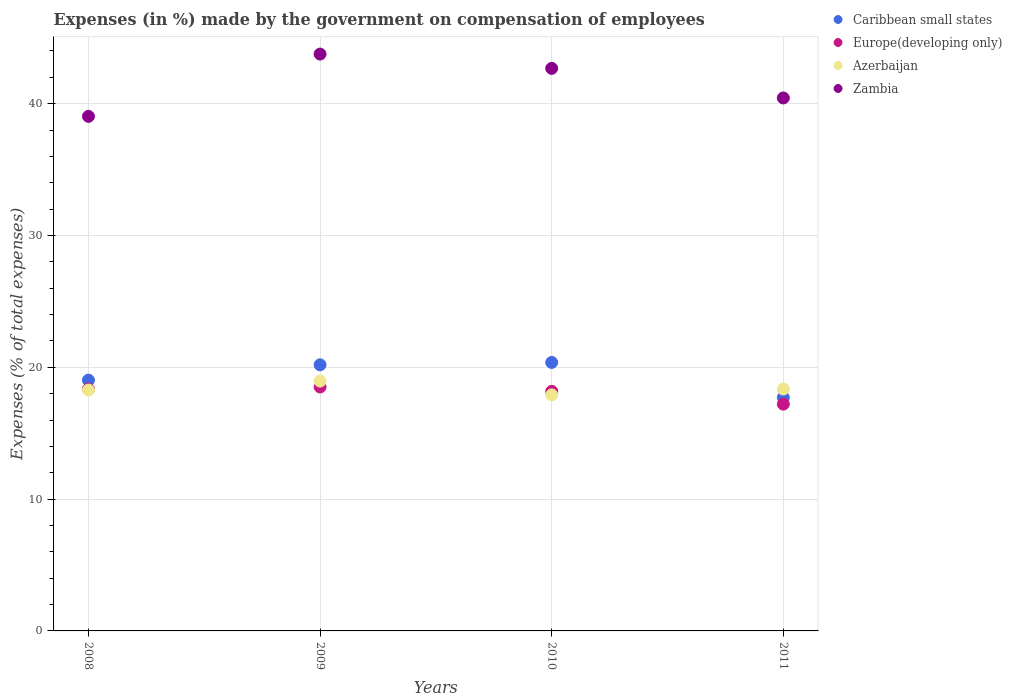What is the percentage of expenses made by the government on compensation of employees in Europe(developing only) in 2008?
Keep it short and to the point. 18.35. Across all years, what is the maximum percentage of expenses made by the government on compensation of employees in Caribbean small states?
Your response must be concise. 20.37. Across all years, what is the minimum percentage of expenses made by the government on compensation of employees in Caribbean small states?
Provide a short and direct response. 17.71. In which year was the percentage of expenses made by the government on compensation of employees in Caribbean small states maximum?
Provide a succinct answer. 2010. In which year was the percentage of expenses made by the government on compensation of employees in Caribbean small states minimum?
Make the answer very short. 2011. What is the total percentage of expenses made by the government on compensation of employees in Europe(developing only) in the graph?
Make the answer very short. 72.23. What is the difference between the percentage of expenses made by the government on compensation of employees in Zambia in 2008 and that in 2009?
Offer a terse response. -4.73. What is the difference between the percentage of expenses made by the government on compensation of employees in Zambia in 2011 and the percentage of expenses made by the government on compensation of employees in Europe(developing only) in 2008?
Offer a very short reply. 22.08. What is the average percentage of expenses made by the government on compensation of employees in Caribbean small states per year?
Make the answer very short. 19.32. In the year 2009, what is the difference between the percentage of expenses made by the government on compensation of employees in Azerbaijan and percentage of expenses made by the government on compensation of employees in Caribbean small states?
Provide a short and direct response. -1.23. In how many years, is the percentage of expenses made by the government on compensation of employees in Azerbaijan greater than 6 %?
Keep it short and to the point. 4. What is the ratio of the percentage of expenses made by the government on compensation of employees in Zambia in 2008 to that in 2010?
Give a very brief answer. 0.91. Is the percentage of expenses made by the government on compensation of employees in Europe(developing only) in 2008 less than that in 2010?
Your response must be concise. No. What is the difference between the highest and the second highest percentage of expenses made by the government on compensation of employees in Zambia?
Make the answer very short. 1.08. What is the difference between the highest and the lowest percentage of expenses made by the government on compensation of employees in Europe(developing only)?
Your response must be concise. 1.3. In how many years, is the percentage of expenses made by the government on compensation of employees in Azerbaijan greater than the average percentage of expenses made by the government on compensation of employees in Azerbaijan taken over all years?
Offer a terse response. 1. Is the sum of the percentage of expenses made by the government on compensation of employees in Europe(developing only) in 2009 and 2010 greater than the maximum percentage of expenses made by the government on compensation of employees in Caribbean small states across all years?
Ensure brevity in your answer.  Yes. Is it the case that in every year, the sum of the percentage of expenses made by the government on compensation of employees in Zambia and percentage of expenses made by the government on compensation of employees in Europe(developing only)  is greater than the sum of percentage of expenses made by the government on compensation of employees in Caribbean small states and percentage of expenses made by the government on compensation of employees in Azerbaijan?
Make the answer very short. Yes. Does the percentage of expenses made by the government on compensation of employees in Europe(developing only) monotonically increase over the years?
Ensure brevity in your answer.  No. Is the percentage of expenses made by the government on compensation of employees in Zambia strictly greater than the percentage of expenses made by the government on compensation of employees in Azerbaijan over the years?
Your answer should be very brief. Yes. What is the difference between two consecutive major ticks on the Y-axis?
Provide a succinct answer. 10. Are the values on the major ticks of Y-axis written in scientific E-notation?
Your response must be concise. No. Does the graph contain grids?
Provide a short and direct response. Yes. Where does the legend appear in the graph?
Make the answer very short. Top right. How many legend labels are there?
Offer a very short reply. 4. How are the legend labels stacked?
Your answer should be very brief. Vertical. What is the title of the graph?
Keep it short and to the point. Expenses (in %) made by the government on compensation of employees. Does "El Salvador" appear as one of the legend labels in the graph?
Your answer should be very brief. No. What is the label or title of the Y-axis?
Your response must be concise. Expenses (% of total expenses). What is the Expenses (% of total expenses) in Caribbean small states in 2008?
Keep it short and to the point. 19.03. What is the Expenses (% of total expenses) of Europe(developing only) in 2008?
Give a very brief answer. 18.35. What is the Expenses (% of total expenses) of Azerbaijan in 2008?
Your response must be concise. 18.27. What is the Expenses (% of total expenses) of Zambia in 2008?
Keep it short and to the point. 39.03. What is the Expenses (% of total expenses) of Caribbean small states in 2009?
Ensure brevity in your answer.  20.19. What is the Expenses (% of total expenses) in Europe(developing only) in 2009?
Make the answer very short. 18.5. What is the Expenses (% of total expenses) in Azerbaijan in 2009?
Provide a short and direct response. 18.95. What is the Expenses (% of total expenses) in Zambia in 2009?
Give a very brief answer. 43.76. What is the Expenses (% of total expenses) in Caribbean small states in 2010?
Your answer should be compact. 20.37. What is the Expenses (% of total expenses) of Europe(developing only) in 2010?
Your answer should be very brief. 18.17. What is the Expenses (% of total expenses) in Azerbaijan in 2010?
Give a very brief answer. 17.91. What is the Expenses (% of total expenses) of Zambia in 2010?
Make the answer very short. 42.68. What is the Expenses (% of total expenses) of Caribbean small states in 2011?
Your answer should be compact. 17.71. What is the Expenses (% of total expenses) in Europe(developing only) in 2011?
Offer a terse response. 17.21. What is the Expenses (% of total expenses) in Azerbaijan in 2011?
Provide a short and direct response. 18.35. What is the Expenses (% of total expenses) of Zambia in 2011?
Your response must be concise. 40.43. Across all years, what is the maximum Expenses (% of total expenses) in Caribbean small states?
Provide a succinct answer. 20.37. Across all years, what is the maximum Expenses (% of total expenses) in Europe(developing only)?
Your response must be concise. 18.5. Across all years, what is the maximum Expenses (% of total expenses) in Azerbaijan?
Provide a succinct answer. 18.95. Across all years, what is the maximum Expenses (% of total expenses) in Zambia?
Give a very brief answer. 43.76. Across all years, what is the minimum Expenses (% of total expenses) of Caribbean small states?
Give a very brief answer. 17.71. Across all years, what is the minimum Expenses (% of total expenses) in Europe(developing only)?
Give a very brief answer. 17.21. Across all years, what is the minimum Expenses (% of total expenses) in Azerbaijan?
Your answer should be compact. 17.91. Across all years, what is the minimum Expenses (% of total expenses) in Zambia?
Provide a short and direct response. 39.03. What is the total Expenses (% of total expenses) of Caribbean small states in the graph?
Your answer should be very brief. 77.29. What is the total Expenses (% of total expenses) in Europe(developing only) in the graph?
Your answer should be very brief. 72.23. What is the total Expenses (% of total expenses) in Azerbaijan in the graph?
Your answer should be compact. 73.48. What is the total Expenses (% of total expenses) in Zambia in the graph?
Give a very brief answer. 165.9. What is the difference between the Expenses (% of total expenses) in Caribbean small states in 2008 and that in 2009?
Your answer should be very brief. -1.16. What is the difference between the Expenses (% of total expenses) of Europe(developing only) in 2008 and that in 2009?
Give a very brief answer. -0.16. What is the difference between the Expenses (% of total expenses) of Azerbaijan in 2008 and that in 2009?
Your response must be concise. -0.68. What is the difference between the Expenses (% of total expenses) in Zambia in 2008 and that in 2009?
Give a very brief answer. -4.73. What is the difference between the Expenses (% of total expenses) in Caribbean small states in 2008 and that in 2010?
Keep it short and to the point. -1.34. What is the difference between the Expenses (% of total expenses) of Europe(developing only) in 2008 and that in 2010?
Provide a short and direct response. 0.17. What is the difference between the Expenses (% of total expenses) of Azerbaijan in 2008 and that in 2010?
Provide a succinct answer. 0.37. What is the difference between the Expenses (% of total expenses) in Zambia in 2008 and that in 2010?
Offer a very short reply. -3.64. What is the difference between the Expenses (% of total expenses) in Caribbean small states in 2008 and that in 2011?
Your answer should be compact. 1.32. What is the difference between the Expenses (% of total expenses) in Europe(developing only) in 2008 and that in 2011?
Your answer should be very brief. 1.14. What is the difference between the Expenses (% of total expenses) of Azerbaijan in 2008 and that in 2011?
Make the answer very short. -0.07. What is the difference between the Expenses (% of total expenses) in Zambia in 2008 and that in 2011?
Offer a terse response. -1.4. What is the difference between the Expenses (% of total expenses) of Caribbean small states in 2009 and that in 2010?
Make the answer very short. -0.18. What is the difference between the Expenses (% of total expenses) of Europe(developing only) in 2009 and that in 2010?
Ensure brevity in your answer.  0.33. What is the difference between the Expenses (% of total expenses) of Azerbaijan in 2009 and that in 2010?
Give a very brief answer. 1.04. What is the difference between the Expenses (% of total expenses) of Zambia in 2009 and that in 2010?
Offer a terse response. 1.08. What is the difference between the Expenses (% of total expenses) in Caribbean small states in 2009 and that in 2011?
Your response must be concise. 2.48. What is the difference between the Expenses (% of total expenses) in Europe(developing only) in 2009 and that in 2011?
Offer a terse response. 1.3. What is the difference between the Expenses (% of total expenses) of Azerbaijan in 2009 and that in 2011?
Offer a very short reply. 0.6. What is the difference between the Expenses (% of total expenses) of Zambia in 2009 and that in 2011?
Your answer should be compact. 3.33. What is the difference between the Expenses (% of total expenses) in Caribbean small states in 2010 and that in 2011?
Your answer should be compact. 2.66. What is the difference between the Expenses (% of total expenses) in Europe(developing only) in 2010 and that in 2011?
Offer a terse response. 0.97. What is the difference between the Expenses (% of total expenses) of Azerbaijan in 2010 and that in 2011?
Provide a short and direct response. -0.44. What is the difference between the Expenses (% of total expenses) of Zambia in 2010 and that in 2011?
Your response must be concise. 2.24. What is the difference between the Expenses (% of total expenses) of Caribbean small states in 2008 and the Expenses (% of total expenses) of Europe(developing only) in 2009?
Provide a succinct answer. 0.52. What is the difference between the Expenses (% of total expenses) of Caribbean small states in 2008 and the Expenses (% of total expenses) of Azerbaijan in 2009?
Keep it short and to the point. 0.07. What is the difference between the Expenses (% of total expenses) of Caribbean small states in 2008 and the Expenses (% of total expenses) of Zambia in 2009?
Give a very brief answer. -24.73. What is the difference between the Expenses (% of total expenses) in Europe(developing only) in 2008 and the Expenses (% of total expenses) in Azerbaijan in 2009?
Your answer should be very brief. -0.6. What is the difference between the Expenses (% of total expenses) of Europe(developing only) in 2008 and the Expenses (% of total expenses) of Zambia in 2009?
Make the answer very short. -25.41. What is the difference between the Expenses (% of total expenses) of Azerbaijan in 2008 and the Expenses (% of total expenses) of Zambia in 2009?
Make the answer very short. -25.49. What is the difference between the Expenses (% of total expenses) in Caribbean small states in 2008 and the Expenses (% of total expenses) in Europe(developing only) in 2010?
Give a very brief answer. 0.85. What is the difference between the Expenses (% of total expenses) of Caribbean small states in 2008 and the Expenses (% of total expenses) of Azerbaijan in 2010?
Provide a succinct answer. 1.12. What is the difference between the Expenses (% of total expenses) of Caribbean small states in 2008 and the Expenses (% of total expenses) of Zambia in 2010?
Make the answer very short. -23.65. What is the difference between the Expenses (% of total expenses) in Europe(developing only) in 2008 and the Expenses (% of total expenses) in Azerbaijan in 2010?
Your response must be concise. 0.44. What is the difference between the Expenses (% of total expenses) of Europe(developing only) in 2008 and the Expenses (% of total expenses) of Zambia in 2010?
Offer a terse response. -24.33. What is the difference between the Expenses (% of total expenses) of Azerbaijan in 2008 and the Expenses (% of total expenses) of Zambia in 2010?
Make the answer very short. -24.4. What is the difference between the Expenses (% of total expenses) in Caribbean small states in 2008 and the Expenses (% of total expenses) in Europe(developing only) in 2011?
Ensure brevity in your answer.  1.82. What is the difference between the Expenses (% of total expenses) in Caribbean small states in 2008 and the Expenses (% of total expenses) in Azerbaijan in 2011?
Give a very brief answer. 0.68. What is the difference between the Expenses (% of total expenses) of Caribbean small states in 2008 and the Expenses (% of total expenses) of Zambia in 2011?
Offer a terse response. -21.41. What is the difference between the Expenses (% of total expenses) in Europe(developing only) in 2008 and the Expenses (% of total expenses) in Zambia in 2011?
Give a very brief answer. -22.08. What is the difference between the Expenses (% of total expenses) of Azerbaijan in 2008 and the Expenses (% of total expenses) of Zambia in 2011?
Keep it short and to the point. -22.16. What is the difference between the Expenses (% of total expenses) in Caribbean small states in 2009 and the Expenses (% of total expenses) in Europe(developing only) in 2010?
Make the answer very short. 2.01. What is the difference between the Expenses (% of total expenses) in Caribbean small states in 2009 and the Expenses (% of total expenses) in Azerbaijan in 2010?
Make the answer very short. 2.28. What is the difference between the Expenses (% of total expenses) in Caribbean small states in 2009 and the Expenses (% of total expenses) in Zambia in 2010?
Provide a short and direct response. -22.49. What is the difference between the Expenses (% of total expenses) in Europe(developing only) in 2009 and the Expenses (% of total expenses) in Azerbaijan in 2010?
Keep it short and to the point. 0.6. What is the difference between the Expenses (% of total expenses) in Europe(developing only) in 2009 and the Expenses (% of total expenses) in Zambia in 2010?
Keep it short and to the point. -24.17. What is the difference between the Expenses (% of total expenses) of Azerbaijan in 2009 and the Expenses (% of total expenses) of Zambia in 2010?
Your response must be concise. -23.72. What is the difference between the Expenses (% of total expenses) in Caribbean small states in 2009 and the Expenses (% of total expenses) in Europe(developing only) in 2011?
Offer a very short reply. 2.98. What is the difference between the Expenses (% of total expenses) in Caribbean small states in 2009 and the Expenses (% of total expenses) in Azerbaijan in 2011?
Keep it short and to the point. 1.84. What is the difference between the Expenses (% of total expenses) in Caribbean small states in 2009 and the Expenses (% of total expenses) in Zambia in 2011?
Offer a terse response. -20.24. What is the difference between the Expenses (% of total expenses) in Europe(developing only) in 2009 and the Expenses (% of total expenses) in Azerbaijan in 2011?
Provide a succinct answer. 0.16. What is the difference between the Expenses (% of total expenses) in Europe(developing only) in 2009 and the Expenses (% of total expenses) in Zambia in 2011?
Your response must be concise. -21.93. What is the difference between the Expenses (% of total expenses) of Azerbaijan in 2009 and the Expenses (% of total expenses) of Zambia in 2011?
Make the answer very short. -21.48. What is the difference between the Expenses (% of total expenses) in Caribbean small states in 2010 and the Expenses (% of total expenses) in Europe(developing only) in 2011?
Provide a short and direct response. 3.16. What is the difference between the Expenses (% of total expenses) of Caribbean small states in 2010 and the Expenses (% of total expenses) of Azerbaijan in 2011?
Provide a short and direct response. 2.02. What is the difference between the Expenses (% of total expenses) of Caribbean small states in 2010 and the Expenses (% of total expenses) of Zambia in 2011?
Your answer should be compact. -20.06. What is the difference between the Expenses (% of total expenses) in Europe(developing only) in 2010 and the Expenses (% of total expenses) in Azerbaijan in 2011?
Your answer should be very brief. -0.17. What is the difference between the Expenses (% of total expenses) in Europe(developing only) in 2010 and the Expenses (% of total expenses) in Zambia in 2011?
Your answer should be very brief. -22.26. What is the difference between the Expenses (% of total expenses) of Azerbaijan in 2010 and the Expenses (% of total expenses) of Zambia in 2011?
Give a very brief answer. -22.52. What is the average Expenses (% of total expenses) of Caribbean small states per year?
Keep it short and to the point. 19.32. What is the average Expenses (% of total expenses) of Europe(developing only) per year?
Offer a very short reply. 18.06. What is the average Expenses (% of total expenses) of Azerbaijan per year?
Your answer should be very brief. 18.37. What is the average Expenses (% of total expenses) of Zambia per year?
Give a very brief answer. 41.48. In the year 2008, what is the difference between the Expenses (% of total expenses) of Caribbean small states and Expenses (% of total expenses) of Europe(developing only)?
Ensure brevity in your answer.  0.68. In the year 2008, what is the difference between the Expenses (% of total expenses) of Caribbean small states and Expenses (% of total expenses) of Azerbaijan?
Give a very brief answer. 0.75. In the year 2008, what is the difference between the Expenses (% of total expenses) of Caribbean small states and Expenses (% of total expenses) of Zambia?
Offer a terse response. -20.01. In the year 2008, what is the difference between the Expenses (% of total expenses) in Europe(developing only) and Expenses (% of total expenses) in Azerbaijan?
Ensure brevity in your answer.  0.07. In the year 2008, what is the difference between the Expenses (% of total expenses) in Europe(developing only) and Expenses (% of total expenses) in Zambia?
Keep it short and to the point. -20.69. In the year 2008, what is the difference between the Expenses (% of total expenses) in Azerbaijan and Expenses (% of total expenses) in Zambia?
Your answer should be compact. -20.76. In the year 2009, what is the difference between the Expenses (% of total expenses) in Caribbean small states and Expenses (% of total expenses) in Europe(developing only)?
Your answer should be compact. 1.68. In the year 2009, what is the difference between the Expenses (% of total expenses) in Caribbean small states and Expenses (% of total expenses) in Azerbaijan?
Provide a short and direct response. 1.23. In the year 2009, what is the difference between the Expenses (% of total expenses) of Caribbean small states and Expenses (% of total expenses) of Zambia?
Offer a terse response. -23.57. In the year 2009, what is the difference between the Expenses (% of total expenses) in Europe(developing only) and Expenses (% of total expenses) in Azerbaijan?
Provide a succinct answer. -0.45. In the year 2009, what is the difference between the Expenses (% of total expenses) in Europe(developing only) and Expenses (% of total expenses) in Zambia?
Keep it short and to the point. -25.26. In the year 2009, what is the difference between the Expenses (% of total expenses) of Azerbaijan and Expenses (% of total expenses) of Zambia?
Keep it short and to the point. -24.81. In the year 2010, what is the difference between the Expenses (% of total expenses) in Caribbean small states and Expenses (% of total expenses) in Europe(developing only)?
Your response must be concise. 2.19. In the year 2010, what is the difference between the Expenses (% of total expenses) of Caribbean small states and Expenses (% of total expenses) of Azerbaijan?
Your response must be concise. 2.46. In the year 2010, what is the difference between the Expenses (% of total expenses) in Caribbean small states and Expenses (% of total expenses) in Zambia?
Keep it short and to the point. -22.31. In the year 2010, what is the difference between the Expenses (% of total expenses) of Europe(developing only) and Expenses (% of total expenses) of Azerbaijan?
Provide a short and direct response. 0.27. In the year 2010, what is the difference between the Expenses (% of total expenses) of Europe(developing only) and Expenses (% of total expenses) of Zambia?
Your answer should be very brief. -24.5. In the year 2010, what is the difference between the Expenses (% of total expenses) of Azerbaijan and Expenses (% of total expenses) of Zambia?
Ensure brevity in your answer.  -24.77. In the year 2011, what is the difference between the Expenses (% of total expenses) in Caribbean small states and Expenses (% of total expenses) in Europe(developing only)?
Ensure brevity in your answer.  0.5. In the year 2011, what is the difference between the Expenses (% of total expenses) of Caribbean small states and Expenses (% of total expenses) of Azerbaijan?
Your answer should be compact. -0.64. In the year 2011, what is the difference between the Expenses (% of total expenses) of Caribbean small states and Expenses (% of total expenses) of Zambia?
Give a very brief answer. -22.72. In the year 2011, what is the difference between the Expenses (% of total expenses) in Europe(developing only) and Expenses (% of total expenses) in Azerbaijan?
Your answer should be very brief. -1.14. In the year 2011, what is the difference between the Expenses (% of total expenses) in Europe(developing only) and Expenses (% of total expenses) in Zambia?
Offer a very short reply. -23.23. In the year 2011, what is the difference between the Expenses (% of total expenses) of Azerbaijan and Expenses (% of total expenses) of Zambia?
Make the answer very short. -22.08. What is the ratio of the Expenses (% of total expenses) of Caribbean small states in 2008 to that in 2009?
Your answer should be compact. 0.94. What is the ratio of the Expenses (% of total expenses) of Europe(developing only) in 2008 to that in 2009?
Offer a very short reply. 0.99. What is the ratio of the Expenses (% of total expenses) in Azerbaijan in 2008 to that in 2009?
Keep it short and to the point. 0.96. What is the ratio of the Expenses (% of total expenses) in Zambia in 2008 to that in 2009?
Offer a very short reply. 0.89. What is the ratio of the Expenses (% of total expenses) in Caribbean small states in 2008 to that in 2010?
Offer a very short reply. 0.93. What is the ratio of the Expenses (% of total expenses) in Europe(developing only) in 2008 to that in 2010?
Offer a terse response. 1.01. What is the ratio of the Expenses (% of total expenses) of Azerbaijan in 2008 to that in 2010?
Ensure brevity in your answer.  1.02. What is the ratio of the Expenses (% of total expenses) in Zambia in 2008 to that in 2010?
Offer a terse response. 0.91. What is the ratio of the Expenses (% of total expenses) of Caribbean small states in 2008 to that in 2011?
Give a very brief answer. 1.07. What is the ratio of the Expenses (% of total expenses) in Europe(developing only) in 2008 to that in 2011?
Provide a succinct answer. 1.07. What is the ratio of the Expenses (% of total expenses) in Zambia in 2008 to that in 2011?
Make the answer very short. 0.97. What is the ratio of the Expenses (% of total expenses) in Europe(developing only) in 2009 to that in 2010?
Keep it short and to the point. 1.02. What is the ratio of the Expenses (% of total expenses) in Azerbaijan in 2009 to that in 2010?
Provide a short and direct response. 1.06. What is the ratio of the Expenses (% of total expenses) of Zambia in 2009 to that in 2010?
Provide a succinct answer. 1.03. What is the ratio of the Expenses (% of total expenses) of Caribbean small states in 2009 to that in 2011?
Keep it short and to the point. 1.14. What is the ratio of the Expenses (% of total expenses) of Europe(developing only) in 2009 to that in 2011?
Ensure brevity in your answer.  1.08. What is the ratio of the Expenses (% of total expenses) of Azerbaijan in 2009 to that in 2011?
Your answer should be compact. 1.03. What is the ratio of the Expenses (% of total expenses) in Zambia in 2009 to that in 2011?
Ensure brevity in your answer.  1.08. What is the ratio of the Expenses (% of total expenses) in Caribbean small states in 2010 to that in 2011?
Keep it short and to the point. 1.15. What is the ratio of the Expenses (% of total expenses) of Europe(developing only) in 2010 to that in 2011?
Keep it short and to the point. 1.06. What is the ratio of the Expenses (% of total expenses) of Zambia in 2010 to that in 2011?
Your answer should be very brief. 1.06. What is the difference between the highest and the second highest Expenses (% of total expenses) in Caribbean small states?
Ensure brevity in your answer.  0.18. What is the difference between the highest and the second highest Expenses (% of total expenses) of Europe(developing only)?
Ensure brevity in your answer.  0.16. What is the difference between the highest and the second highest Expenses (% of total expenses) in Azerbaijan?
Offer a very short reply. 0.6. What is the difference between the highest and the second highest Expenses (% of total expenses) in Zambia?
Make the answer very short. 1.08. What is the difference between the highest and the lowest Expenses (% of total expenses) of Caribbean small states?
Make the answer very short. 2.66. What is the difference between the highest and the lowest Expenses (% of total expenses) in Europe(developing only)?
Provide a short and direct response. 1.3. What is the difference between the highest and the lowest Expenses (% of total expenses) in Azerbaijan?
Offer a terse response. 1.04. What is the difference between the highest and the lowest Expenses (% of total expenses) in Zambia?
Offer a terse response. 4.73. 